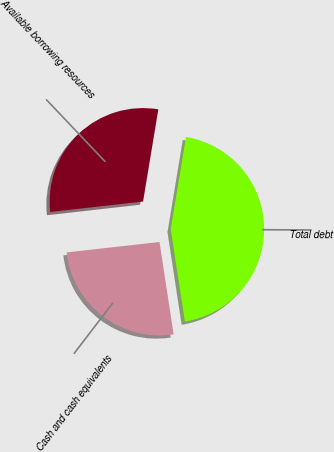Convert chart to OTSL. <chart><loc_0><loc_0><loc_500><loc_500><pie_chart><fcel>Cash and cash equivalents<fcel>Total debt<fcel>Available borrowing resources<nl><fcel>25.63%<fcel>44.97%<fcel>29.4%<nl></chart> 